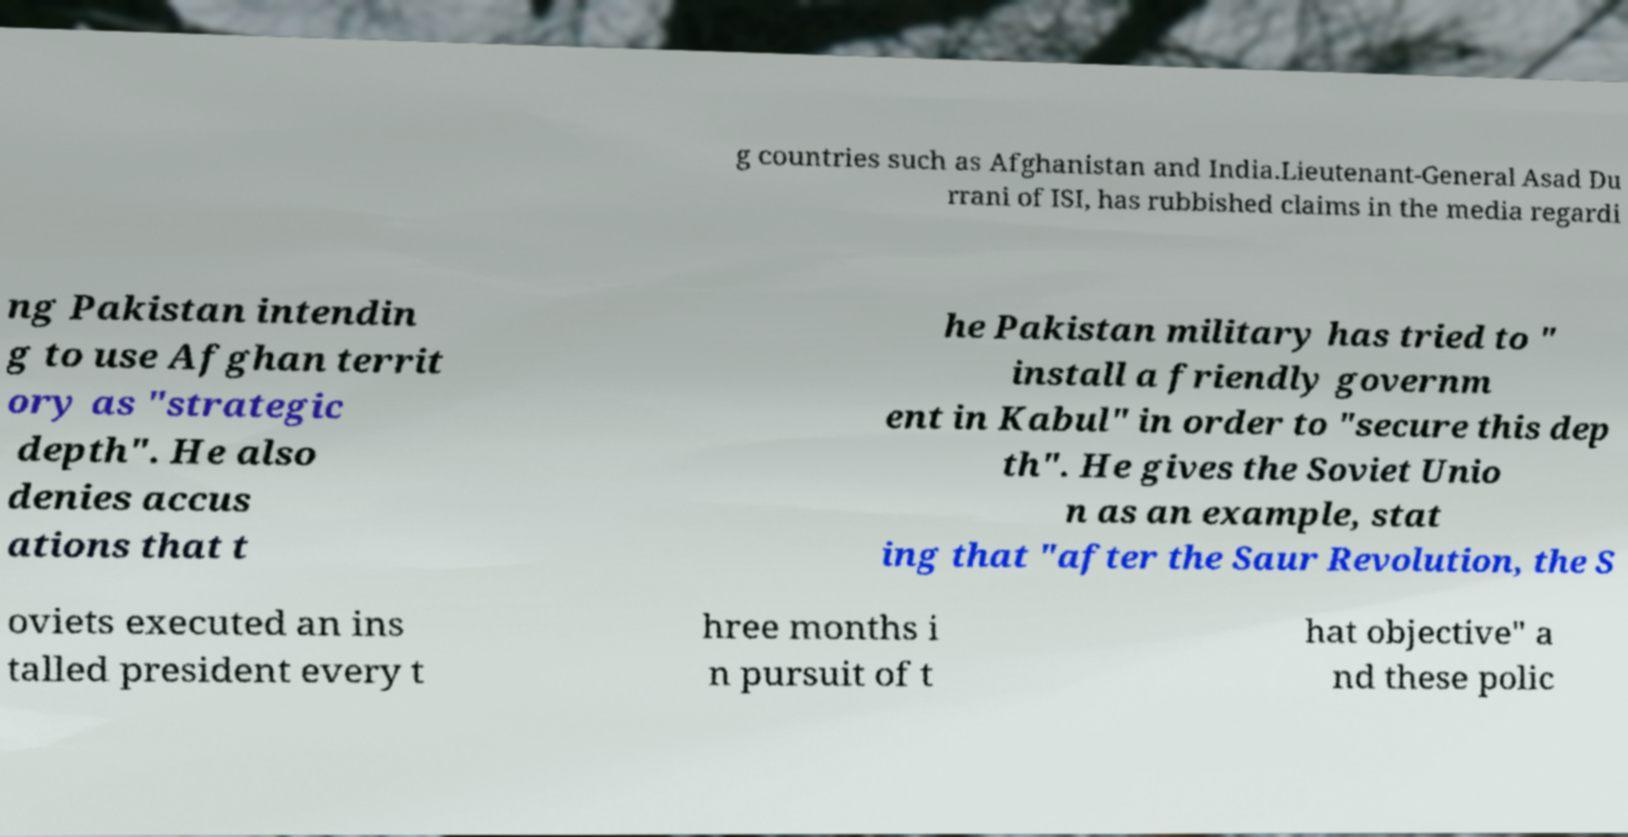There's text embedded in this image that I need extracted. Can you transcribe it verbatim? g countries such as Afghanistan and India.Lieutenant-General Asad Du rrani of ISI, has rubbished claims in the media regardi ng Pakistan intendin g to use Afghan territ ory as "strategic depth". He also denies accus ations that t he Pakistan military has tried to " install a friendly governm ent in Kabul" in order to "secure this dep th". He gives the Soviet Unio n as an example, stat ing that "after the Saur Revolution, the S oviets executed an ins talled president every t hree months i n pursuit of t hat objective" a nd these polic 